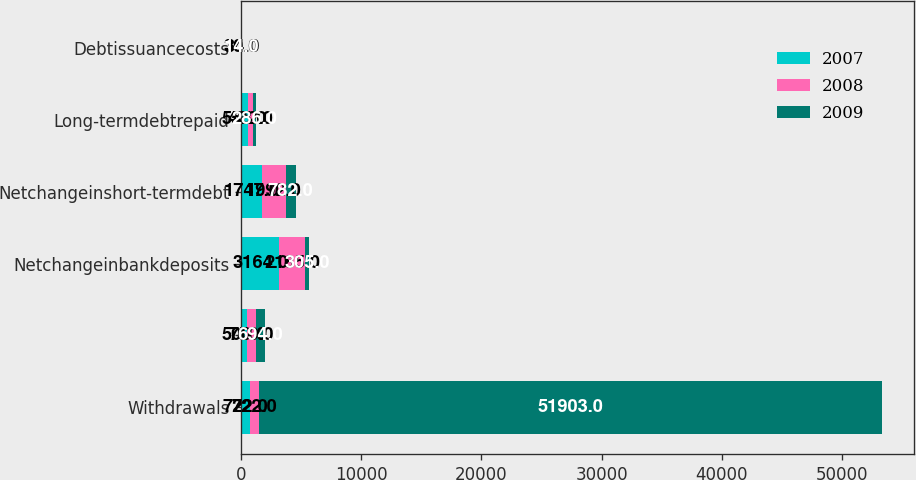Convert chart. <chart><loc_0><loc_0><loc_500><loc_500><stacked_bar_chart><ecel><fcel>Withdrawals<fcel>Unnamed: 2<fcel>Netchangeinbankdeposits<fcel>Netchangeinshort-termdebt<fcel>Long-termdebtrepaid<fcel>Debtissuancecosts<nl><fcel>2007<fcel>722<fcel>500<fcel>3164<fcel>1747<fcel>555<fcel>30<nl><fcel>2008<fcel>722<fcel>750<fcel>2185<fcel>1992<fcel>422<fcel>34<nl><fcel>2009<fcel>51903<fcel>694<fcel>305<fcel>782<fcel>286<fcel>14<nl></chart> 